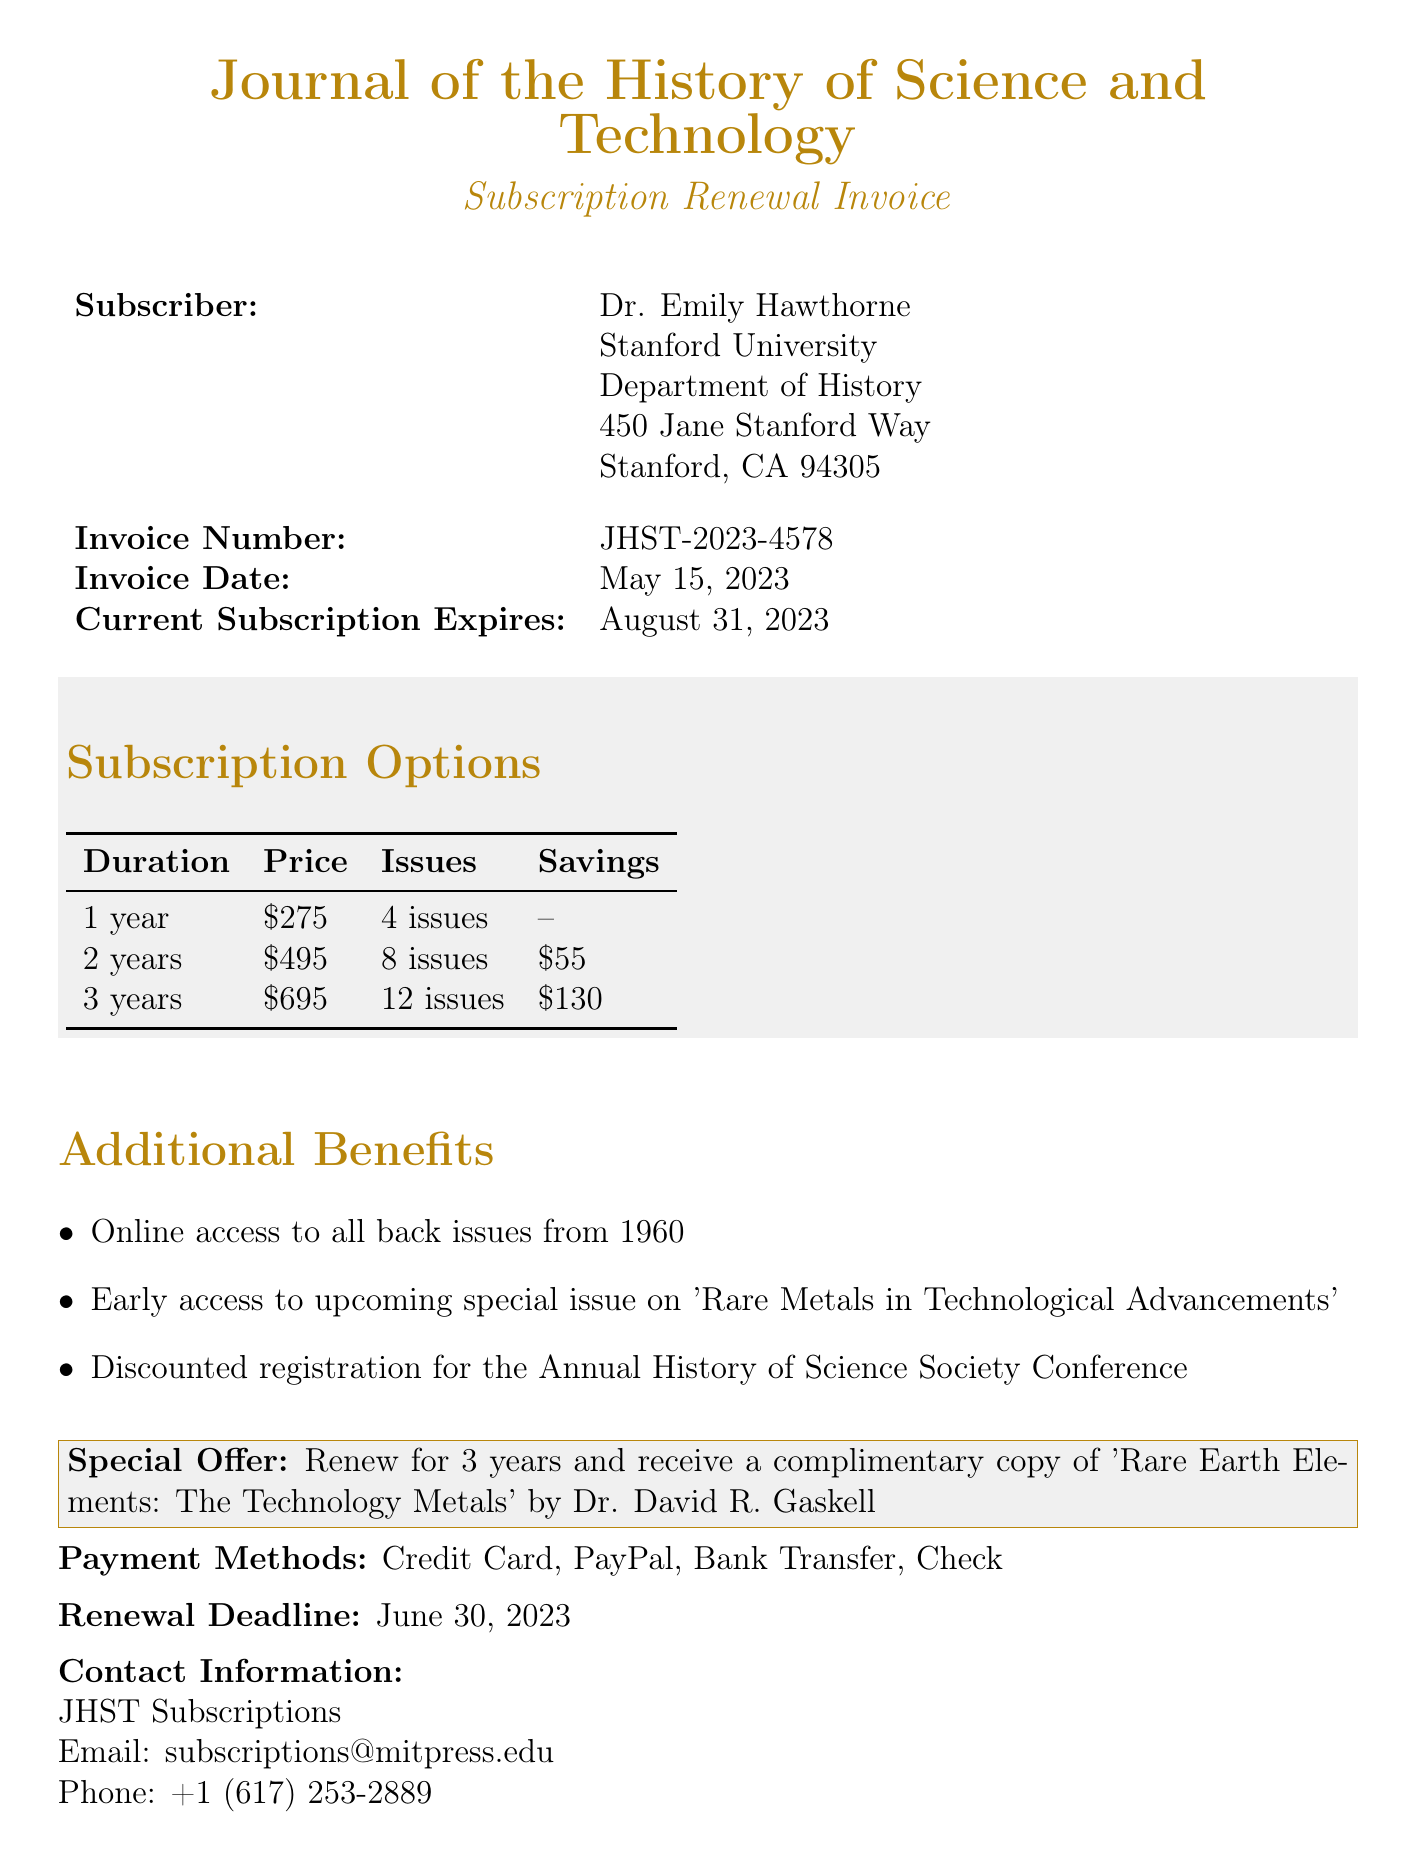What is the invoice number? The invoice number is a unique identifier for the transaction, specified in the document as JHST-2023-4578.
Answer: JHST-2023-4578 Who is the subscriber? The subscriber's name is provided at the beginning of the document, listed as Dr. Emily Hawthorne.
Answer: Dr. Emily Hawthorne What is the price for a two-year subscription? The price for a two-year subscription is explicitly stated in the subscription options section as $495.
Answer: $495 What is one of the additional benefits? The document lists several benefits; one example is online access to all back issues from 1960.
Answer: Online access to all back issues from 1960 What is the deadline for renewal? The renewal deadline is clearly indicated in the document, showing the date by which the renewal must occur.
Answer: June 30, 2023 How much can be saved by subscribing for three years? The savings for a three-year subscription can be calculated from the subscription pricing, which states a saving of $130.
Answer: $130 What is the special offer for renewing for three years? The special offer is specified in the document to incentivize longer subscriptions, detailing the complimentary copy offered.
Answer: A complimentary copy of 'Rare Earth Elements: The Technology Metals' by Dr. David R. Gaskell Which institution is Dr. Emily Hawthorne affiliated with? The document mentions the institution with which the subscriber is affiliated as Stanford University.
Answer: Stanford University 